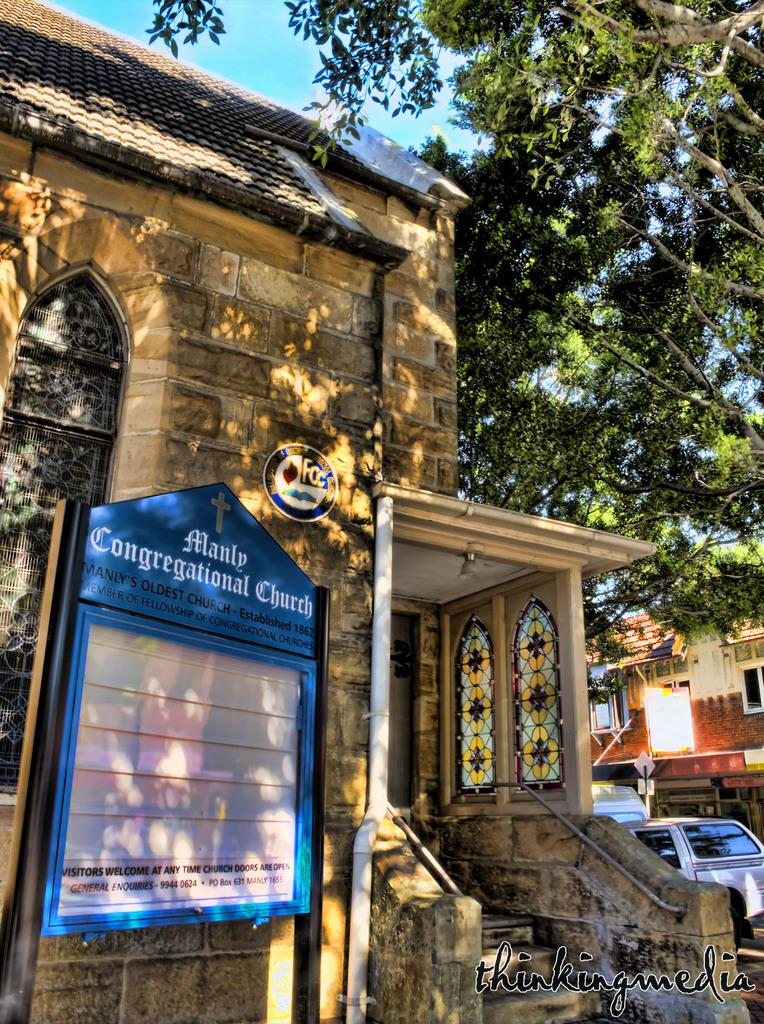What type of building is in the image? There is a church in the image. What is located on the left side of the image? There is a board on the left side of the image. What type of vegetation is on the right side of the image? There is a tree on the right side of the image. What is visible at the top of the image? The sky is visible at the top of the image. Where is the brain located in the image? There is no brain present in the image. What type of alley can be seen behind the church in the image? There is no alley visible in the image; it only shows the church, board, tree, and sky. 